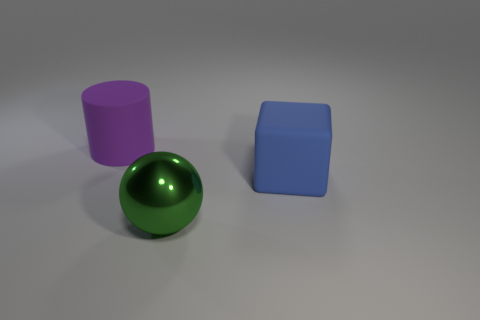Add 3 large matte objects. How many objects exist? 6 Subtract all cylinders. How many objects are left? 2 Add 1 large brown metallic spheres. How many large brown metallic spheres exist? 1 Subtract 0 cyan spheres. How many objects are left? 3 Subtract all large red cylinders. Subtract all large purple matte cylinders. How many objects are left? 2 Add 1 green balls. How many green balls are left? 2 